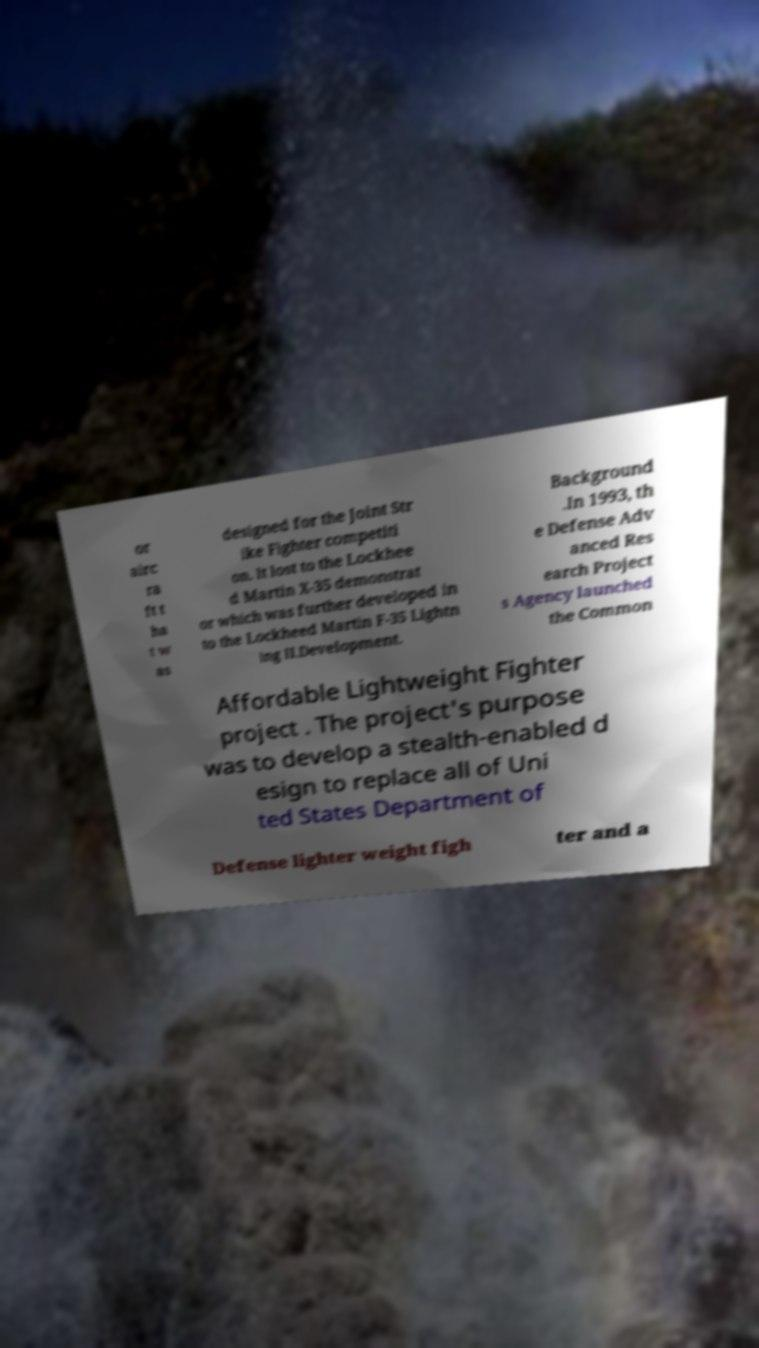Please identify and transcribe the text found in this image. or airc ra ft t ha t w as designed for the Joint Str ike Fighter competiti on. It lost to the Lockhee d Martin X-35 demonstrat or which was further developed in to the Lockheed Martin F-35 Lightn ing II.Development. Background .In 1993, th e Defense Adv anced Res earch Project s Agency launched the Common Affordable Lightweight Fighter project . The project's purpose was to develop a stealth-enabled d esign to replace all of Uni ted States Department of Defense lighter weight figh ter and a 